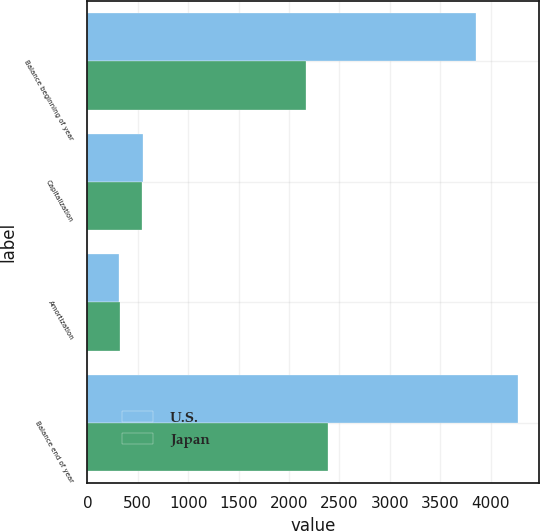<chart> <loc_0><loc_0><loc_500><loc_500><stacked_bar_chart><ecel><fcel>Balance beginning of year<fcel>Capitalization<fcel>Amortization<fcel>Balance end of year<nl><fcel>U.S.<fcel>3857<fcel>555<fcel>318<fcel>4269<nl><fcel>Japan<fcel>2168<fcel>539<fcel>322<fcel>2385<nl></chart> 